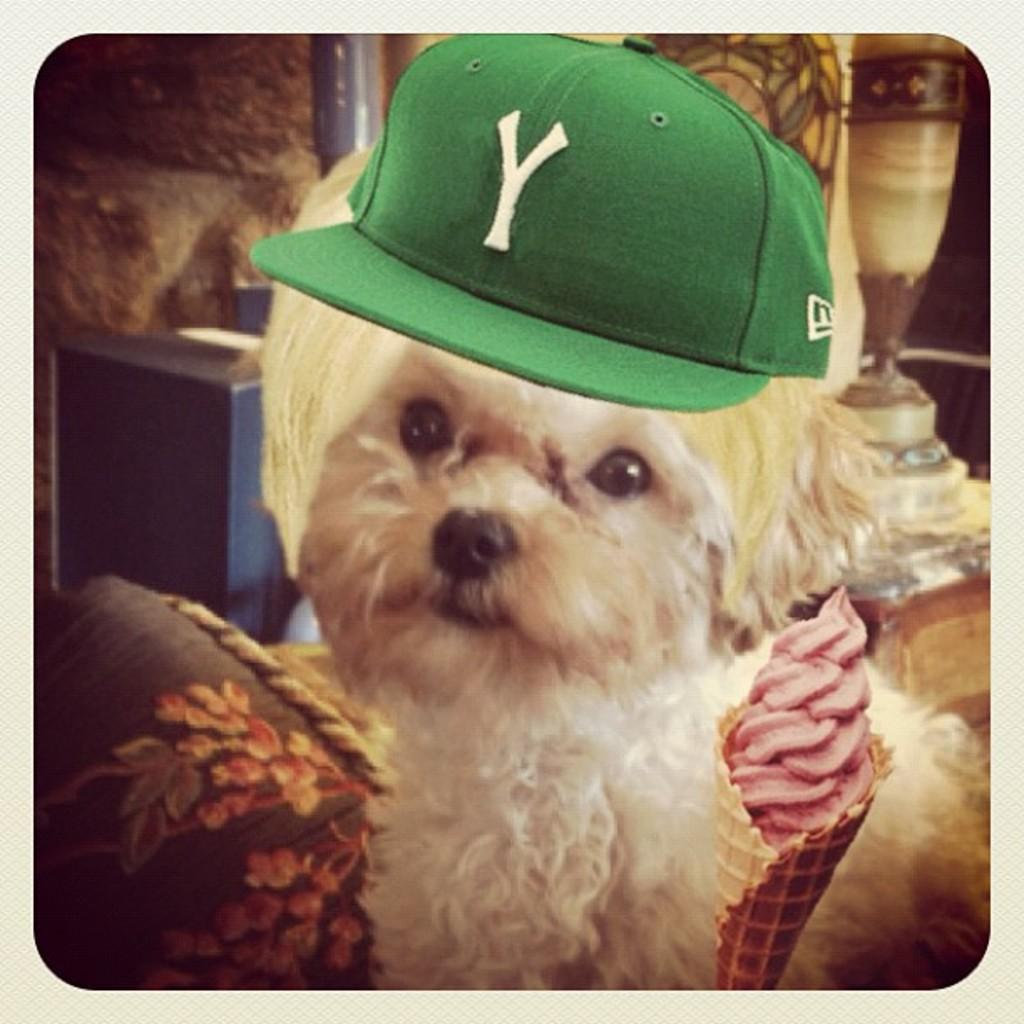What type of animal is present in the image? There is a dog in the image. What is the dog wearing? The dog is wearing a cap. What else can be seen in the image besides the dog? There is an ice cream in the image. What books does the dog wish to read in the image? There are no books present in the image, and the dog's thoughts or wishes cannot be determined from the image. 